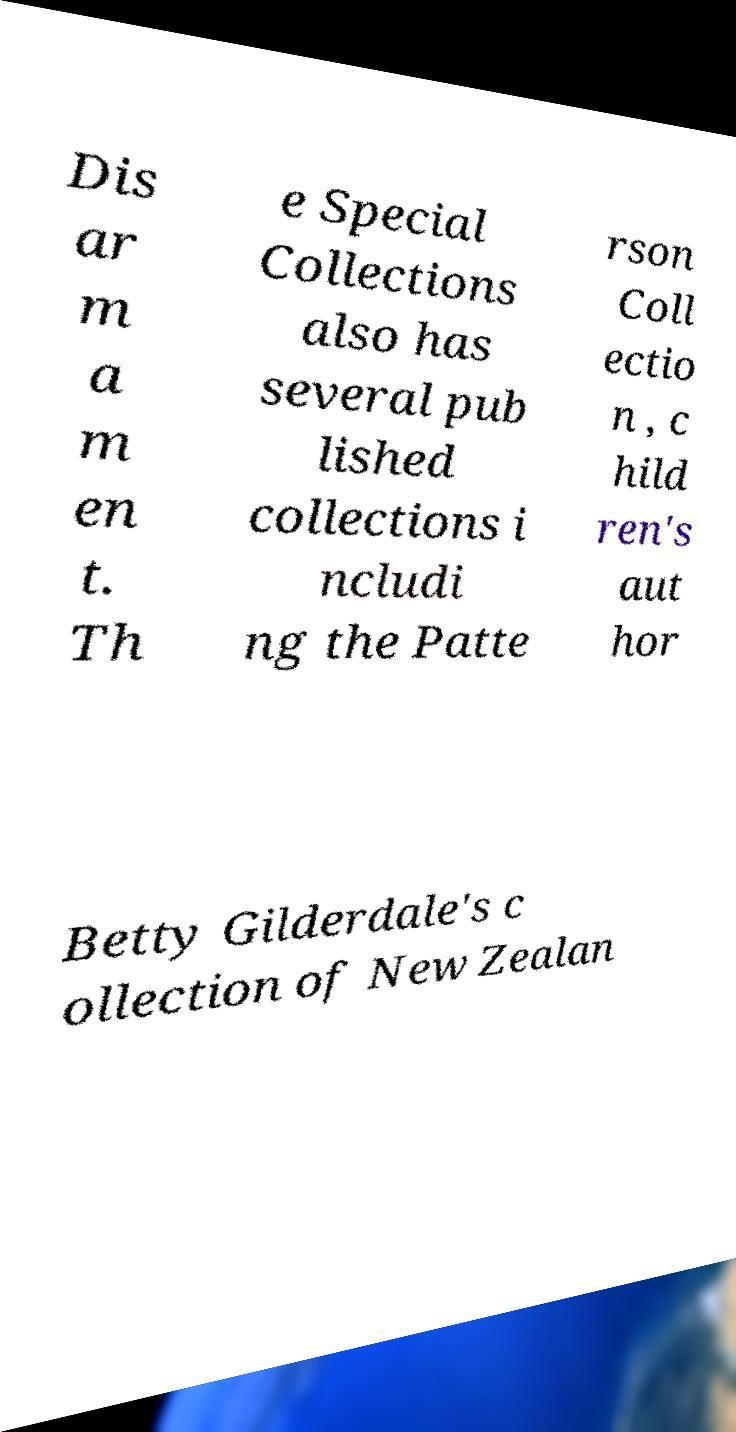What messages or text are displayed in this image? I need them in a readable, typed format. Dis ar m a m en t. Th e Special Collections also has several pub lished collections i ncludi ng the Patte rson Coll ectio n , c hild ren's aut hor Betty Gilderdale's c ollection of New Zealan 